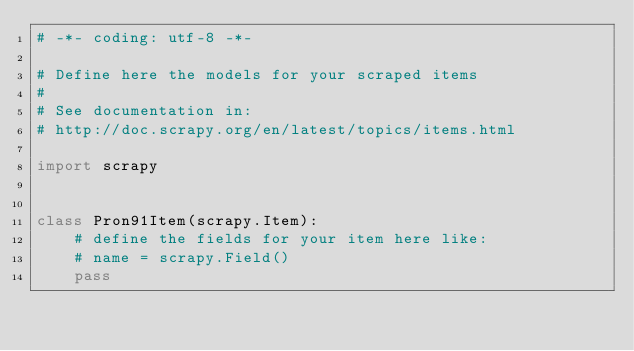Convert code to text. <code><loc_0><loc_0><loc_500><loc_500><_Python_># -*- coding: utf-8 -*-

# Define here the models for your scraped items
#
# See documentation in:
# http://doc.scrapy.org/en/latest/topics/items.html

import scrapy


class Pron91Item(scrapy.Item):
    # define the fields for your item here like:
    # name = scrapy.Field()
    pass
</code> 